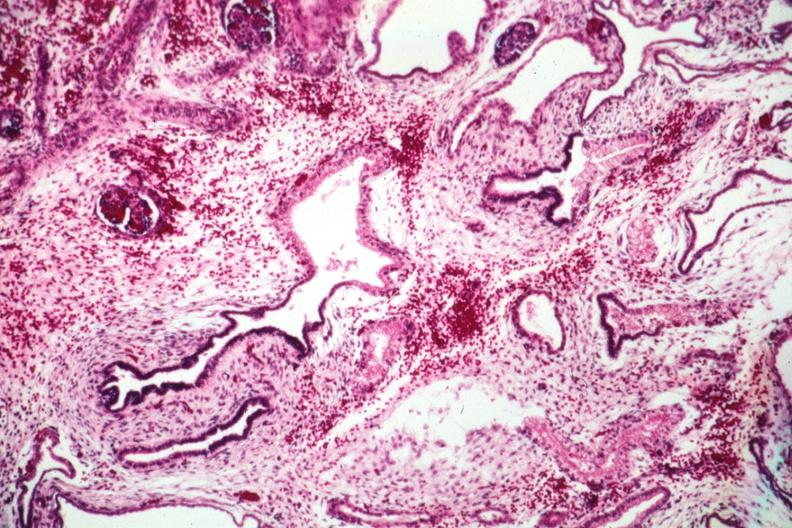where is this?
Answer the question using a single word or phrase. Urinary 